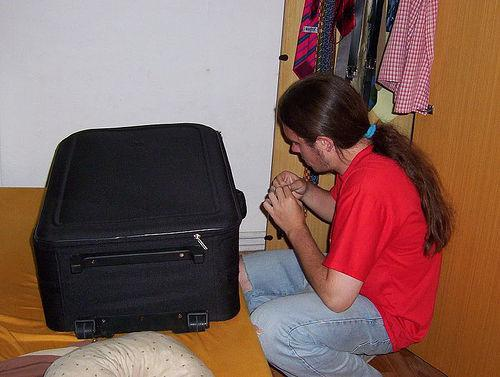Question: what pant leg has the biggest hole?
Choices:
A. The left pant leg.
B. The right pant leg.
C. Both are equal.
D. Neither has holes.
Answer with the letter. Answer: B Question: what material is the closet door?
Choices:
A. Wood.
B. Metal.
C. Plastic.
D. Stone.
Answer with the letter. Answer: A Question: how many hair ties can be seen?
Choices:
A. Two.
B. Three.
C. Eight.
D. One.
Answer with the letter. Answer: D 